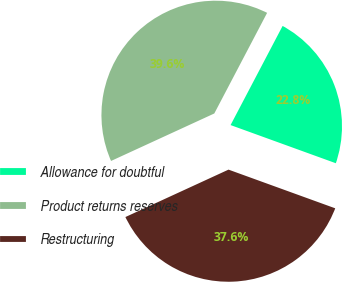<chart> <loc_0><loc_0><loc_500><loc_500><pie_chart><fcel>Allowance for doubtful<fcel>Product returns reserves<fcel>Restructuring<nl><fcel>22.84%<fcel>39.55%<fcel>37.6%<nl></chart> 